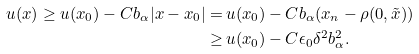<formula> <loc_0><loc_0><loc_500><loc_500>u ( x ) \geq u ( x _ { 0 } ) - C b _ { \alpha } | x - x _ { 0 } | = \, & u ( x _ { 0 } ) - C b _ { \alpha } ( x _ { n } - \rho ( 0 , \tilde { x } ) ) \\ \geq \, & u ( x _ { 0 } ) - C \epsilon _ { 0 } \delta ^ { 2 } b _ { \alpha } ^ { 2 } .</formula> 